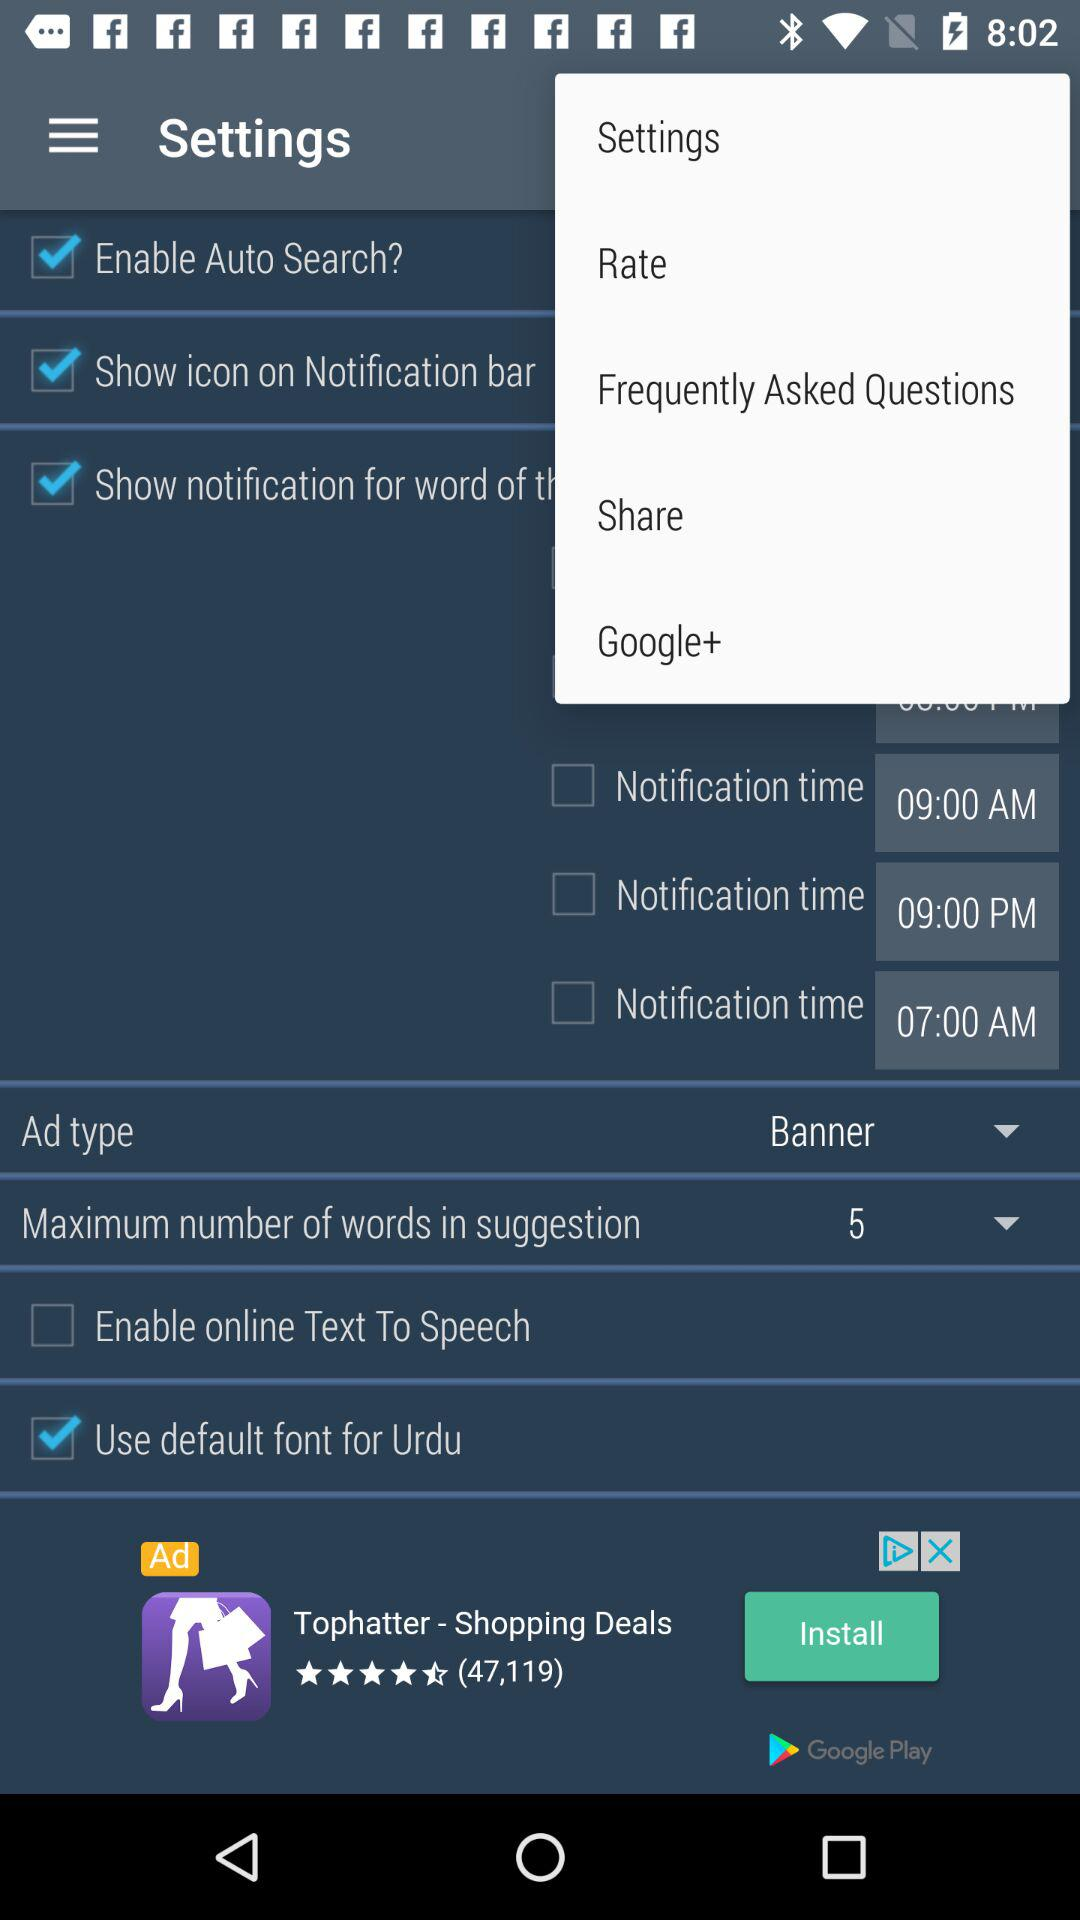What is the ad type? The ad type is "Banner". 